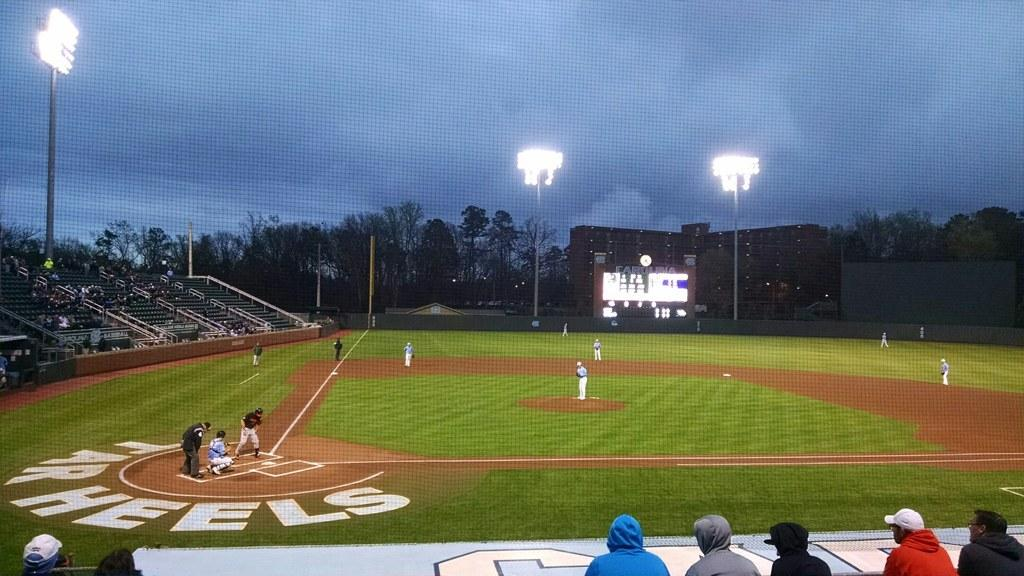<image>
Offer a succinct explanation of the picture presented. cloudy day at baseball game where the Tarwheels play 